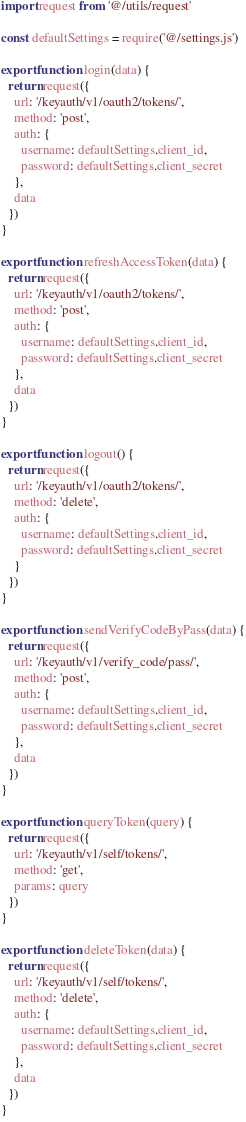Convert code to text. <code><loc_0><loc_0><loc_500><loc_500><_JavaScript_>import request from '@/utils/request'

const defaultSettings = require('@/settings.js')

export function login(data) {
  return request({
    url: '/keyauth/v1/oauth2/tokens/',
    method: 'post',
    auth: {
      username: defaultSettings.client_id,
      password: defaultSettings.client_secret
    },
    data
  })
}

export function refreshAccessToken(data) {
  return request({
    url: '/keyauth/v1/oauth2/tokens/',
    method: 'post',
    auth: {
      username: defaultSettings.client_id,
      password: defaultSettings.client_secret
    },
    data
  })
}

export function logout() {
  return request({
    url: '/keyauth/v1/oauth2/tokens/',
    method: 'delete',
    auth: {
      username: defaultSettings.client_id,
      password: defaultSettings.client_secret
    }
  })
}

export function sendVerifyCodeByPass(data) {
  return request({
    url: '/keyauth/v1/verify_code/pass/',
    method: 'post',
    auth: {
      username: defaultSettings.client_id,
      password: defaultSettings.client_secret
    },
    data
  })
}

export function queryToken(query) {
  return request({
    url: '/keyauth/v1/self/tokens/',
    method: 'get',
    params: query
  })
}

export function deleteToken(data) {
  return request({
    url: '/keyauth/v1/self/tokens/',
    method: 'delete',
    auth: {
      username: defaultSettings.client_id,
      password: defaultSettings.client_secret
    },
    data
  })
}
</code> 